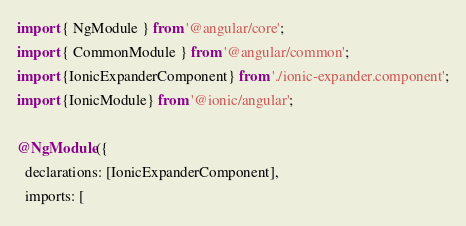<code> <loc_0><loc_0><loc_500><loc_500><_TypeScript_>import { NgModule } from '@angular/core';
import { CommonModule } from '@angular/common';
import {IonicExpanderComponent} from './ionic-expander.component';
import {IonicModule} from '@ionic/angular';

@NgModule({
  declarations: [IonicExpanderComponent],
  imports: [</code> 